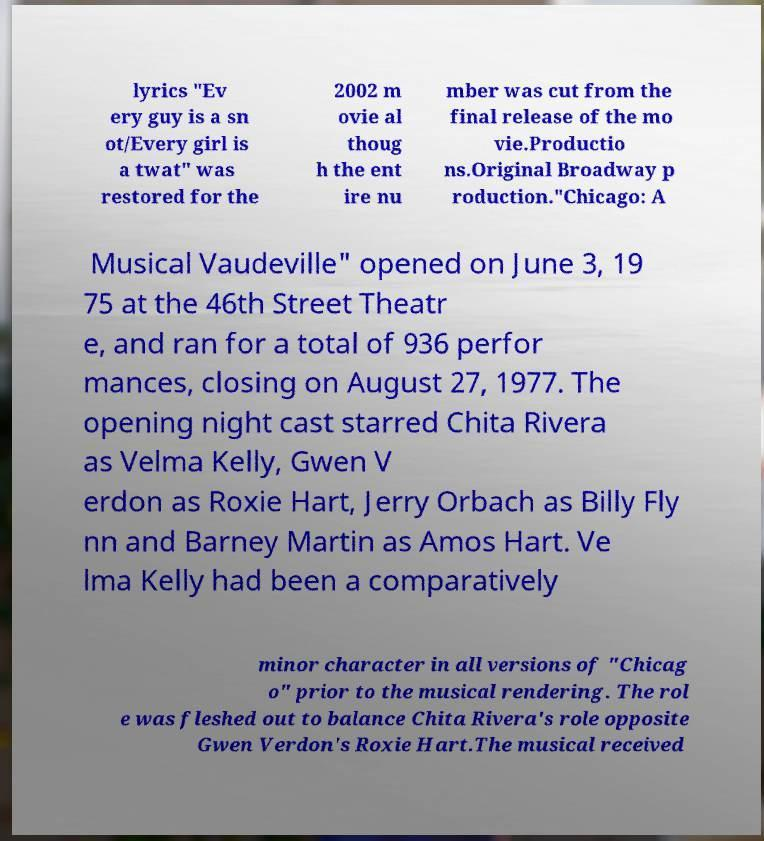What messages or text are displayed in this image? I need them in a readable, typed format. lyrics "Ev ery guy is a sn ot/Every girl is a twat" was restored for the 2002 m ovie al thoug h the ent ire nu mber was cut from the final release of the mo vie.Productio ns.Original Broadway p roduction."Chicago: A Musical Vaudeville" opened on June 3, 19 75 at the 46th Street Theatr e, and ran for a total of 936 perfor mances, closing on August 27, 1977. The opening night cast starred Chita Rivera as Velma Kelly, Gwen V erdon as Roxie Hart, Jerry Orbach as Billy Fly nn and Barney Martin as Amos Hart. Ve lma Kelly had been a comparatively minor character in all versions of "Chicag o" prior to the musical rendering. The rol e was fleshed out to balance Chita Rivera's role opposite Gwen Verdon's Roxie Hart.The musical received 